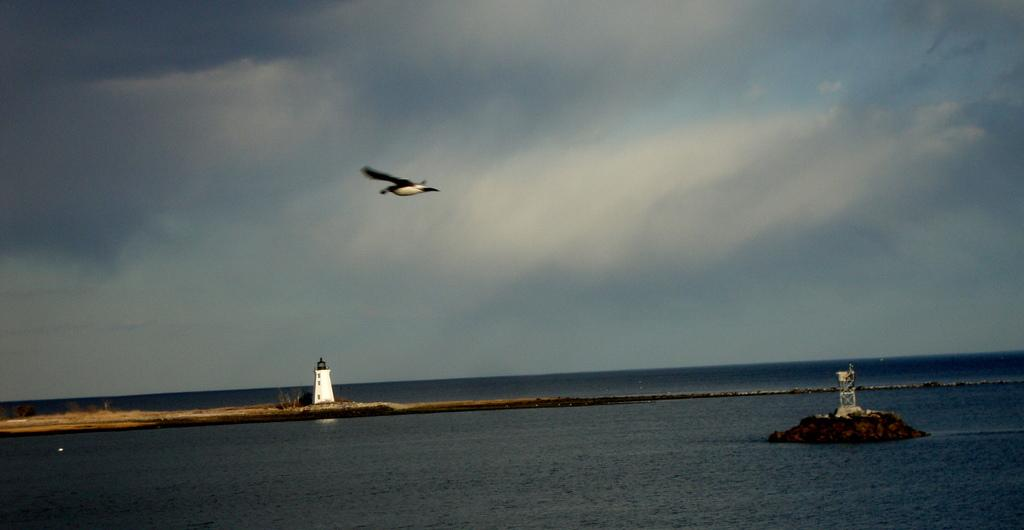What is happening in the sky in the image? There is a bird flying in the sky in the image. What color is the sky in the image? The sky is blue in the image. What is located at the bottom of the image? There is a sea at the bottom of the image. What can be seen on the land in the image? There is a construction on the land in the image. What type of quilt is being used to cover the bird in the image? There is no quilt present in the image; it features a bird flying in the sky. Can you see a boot on the bird's foot in the image? There is no boot visible on the bird's foot in the image. 